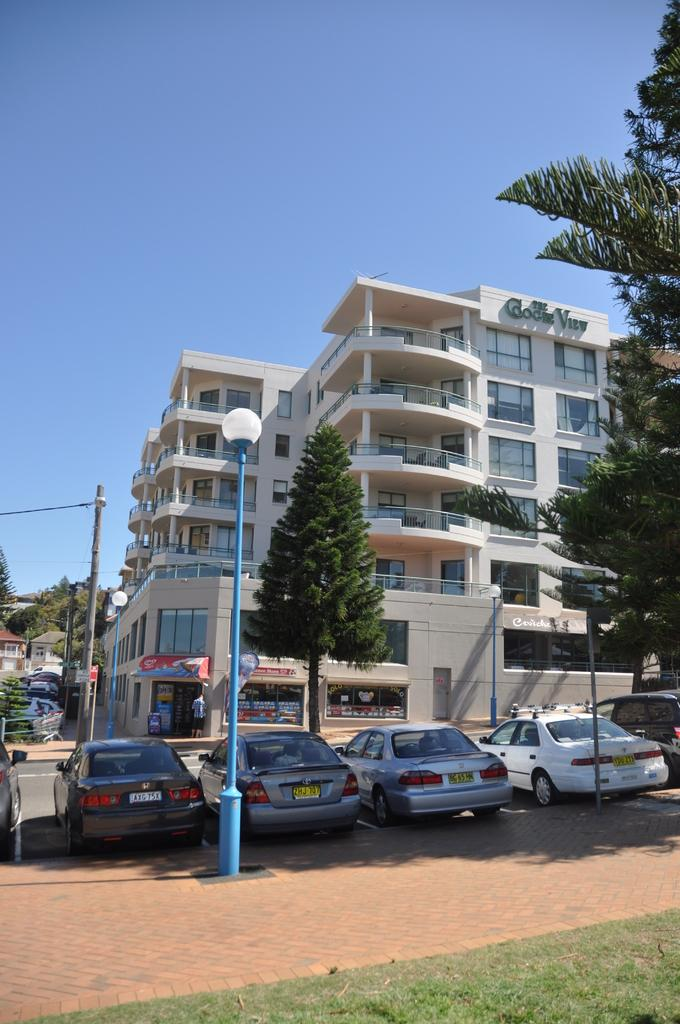What type of vegetation can be seen in the image? There is grass in the image. What else is present in the image besides the grass? There are vehicles in the image. What can be seen in the background of the image? There are trees, buildings, and the sky visible in the background of the image. Where is the coat hanging in the image? There is no coat present in the image. What type of system is being used to control the vehicles in the image? There is no information about a system controlling the vehicles in the image. 